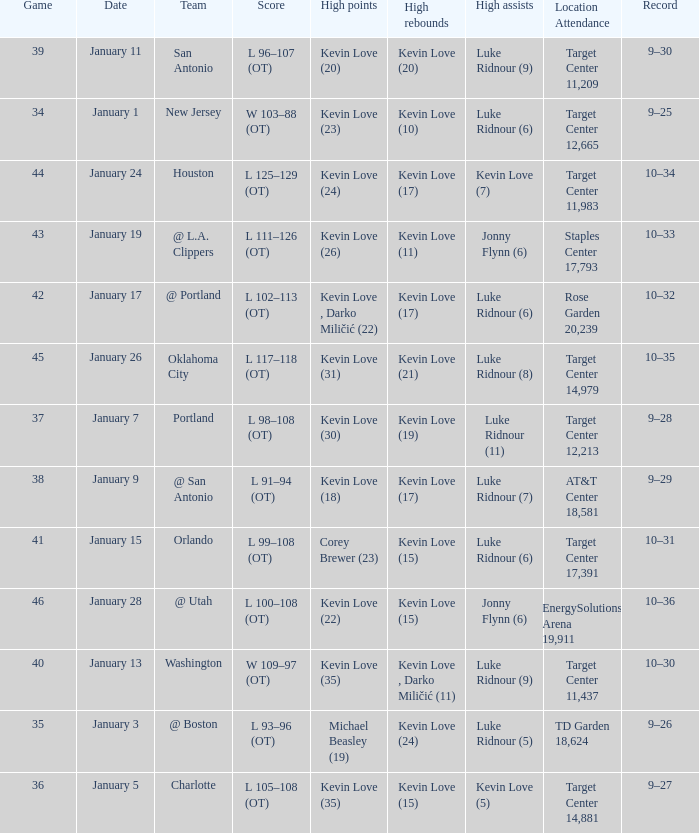What is the top game with team @ l.a. clippers? 43.0. 